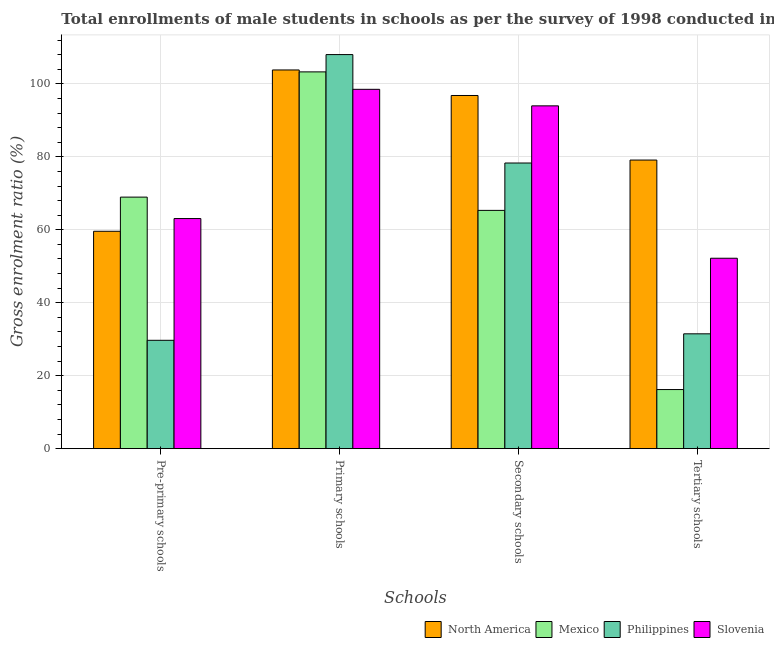Are the number of bars on each tick of the X-axis equal?
Provide a short and direct response. Yes. How many bars are there on the 1st tick from the left?
Your answer should be very brief. 4. How many bars are there on the 4th tick from the right?
Offer a very short reply. 4. What is the label of the 4th group of bars from the left?
Your response must be concise. Tertiary schools. What is the gross enrolment ratio(male) in primary schools in Philippines?
Ensure brevity in your answer.  108.04. Across all countries, what is the maximum gross enrolment ratio(male) in pre-primary schools?
Provide a succinct answer. 68.96. Across all countries, what is the minimum gross enrolment ratio(male) in secondary schools?
Give a very brief answer. 65.33. What is the total gross enrolment ratio(male) in tertiary schools in the graph?
Give a very brief answer. 179.03. What is the difference between the gross enrolment ratio(male) in primary schools in Mexico and that in Slovenia?
Your answer should be compact. 4.78. What is the difference between the gross enrolment ratio(male) in primary schools in Philippines and the gross enrolment ratio(male) in tertiary schools in Mexico?
Provide a short and direct response. 91.83. What is the average gross enrolment ratio(male) in pre-primary schools per country?
Provide a succinct answer. 55.34. What is the difference between the gross enrolment ratio(male) in tertiary schools and gross enrolment ratio(male) in secondary schools in Mexico?
Provide a short and direct response. -49.12. What is the ratio of the gross enrolment ratio(male) in primary schools in North America to that in Mexico?
Provide a succinct answer. 1.01. What is the difference between the highest and the second highest gross enrolment ratio(male) in tertiary schools?
Provide a succinct answer. 26.92. What is the difference between the highest and the lowest gross enrolment ratio(male) in primary schools?
Give a very brief answer. 9.53. Is it the case that in every country, the sum of the gross enrolment ratio(male) in tertiary schools and gross enrolment ratio(male) in secondary schools is greater than the sum of gross enrolment ratio(male) in primary schools and gross enrolment ratio(male) in pre-primary schools?
Your response must be concise. No. What does the 3rd bar from the left in Secondary schools represents?
Give a very brief answer. Philippines. What does the 1st bar from the right in Primary schools represents?
Keep it short and to the point. Slovenia. Are all the bars in the graph horizontal?
Offer a very short reply. No. Are the values on the major ticks of Y-axis written in scientific E-notation?
Your answer should be very brief. No. Does the graph contain any zero values?
Provide a succinct answer. No. Does the graph contain grids?
Your answer should be compact. Yes. How are the legend labels stacked?
Your answer should be very brief. Horizontal. What is the title of the graph?
Provide a succinct answer. Total enrollments of male students in schools as per the survey of 1998 conducted in different countries. Does "Low income" appear as one of the legend labels in the graph?
Your answer should be very brief. No. What is the label or title of the X-axis?
Provide a short and direct response. Schools. What is the label or title of the Y-axis?
Your response must be concise. Gross enrolment ratio (%). What is the Gross enrolment ratio (%) of North America in Pre-primary schools?
Provide a short and direct response. 59.6. What is the Gross enrolment ratio (%) of Mexico in Pre-primary schools?
Your response must be concise. 68.96. What is the Gross enrolment ratio (%) of Philippines in Pre-primary schools?
Provide a succinct answer. 29.71. What is the Gross enrolment ratio (%) of Slovenia in Pre-primary schools?
Your answer should be compact. 63.09. What is the Gross enrolment ratio (%) of North America in Primary schools?
Keep it short and to the point. 103.82. What is the Gross enrolment ratio (%) of Mexico in Primary schools?
Make the answer very short. 103.3. What is the Gross enrolment ratio (%) in Philippines in Primary schools?
Offer a very short reply. 108.04. What is the Gross enrolment ratio (%) of Slovenia in Primary schools?
Offer a very short reply. 98.52. What is the Gross enrolment ratio (%) of North America in Secondary schools?
Your response must be concise. 96.82. What is the Gross enrolment ratio (%) in Mexico in Secondary schools?
Your answer should be compact. 65.33. What is the Gross enrolment ratio (%) of Philippines in Secondary schools?
Your response must be concise. 78.31. What is the Gross enrolment ratio (%) of Slovenia in Secondary schools?
Keep it short and to the point. 93.98. What is the Gross enrolment ratio (%) of North America in Tertiary schools?
Provide a short and direct response. 79.12. What is the Gross enrolment ratio (%) in Mexico in Tertiary schools?
Your answer should be compact. 16.21. What is the Gross enrolment ratio (%) in Philippines in Tertiary schools?
Ensure brevity in your answer.  31.49. What is the Gross enrolment ratio (%) in Slovenia in Tertiary schools?
Provide a short and direct response. 52.21. Across all Schools, what is the maximum Gross enrolment ratio (%) in North America?
Provide a succinct answer. 103.82. Across all Schools, what is the maximum Gross enrolment ratio (%) in Mexico?
Your response must be concise. 103.3. Across all Schools, what is the maximum Gross enrolment ratio (%) in Philippines?
Provide a succinct answer. 108.04. Across all Schools, what is the maximum Gross enrolment ratio (%) of Slovenia?
Your answer should be very brief. 98.52. Across all Schools, what is the minimum Gross enrolment ratio (%) in North America?
Provide a succinct answer. 59.6. Across all Schools, what is the minimum Gross enrolment ratio (%) of Mexico?
Give a very brief answer. 16.21. Across all Schools, what is the minimum Gross enrolment ratio (%) in Philippines?
Offer a very short reply. 29.71. Across all Schools, what is the minimum Gross enrolment ratio (%) in Slovenia?
Provide a succinct answer. 52.21. What is the total Gross enrolment ratio (%) of North America in the graph?
Provide a succinct answer. 339.37. What is the total Gross enrolment ratio (%) in Mexico in the graph?
Your answer should be compact. 253.8. What is the total Gross enrolment ratio (%) in Philippines in the graph?
Offer a terse response. 247.55. What is the total Gross enrolment ratio (%) in Slovenia in the graph?
Give a very brief answer. 307.79. What is the difference between the Gross enrolment ratio (%) of North America in Pre-primary schools and that in Primary schools?
Offer a very short reply. -44.22. What is the difference between the Gross enrolment ratio (%) of Mexico in Pre-primary schools and that in Primary schools?
Your answer should be very brief. -34.33. What is the difference between the Gross enrolment ratio (%) in Philippines in Pre-primary schools and that in Primary schools?
Keep it short and to the point. -78.33. What is the difference between the Gross enrolment ratio (%) of Slovenia in Pre-primary schools and that in Primary schools?
Provide a short and direct response. -35.43. What is the difference between the Gross enrolment ratio (%) in North America in Pre-primary schools and that in Secondary schools?
Provide a short and direct response. -37.22. What is the difference between the Gross enrolment ratio (%) in Mexico in Pre-primary schools and that in Secondary schools?
Provide a succinct answer. 3.63. What is the difference between the Gross enrolment ratio (%) in Philippines in Pre-primary schools and that in Secondary schools?
Offer a terse response. -48.6. What is the difference between the Gross enrolment ratio (%) in Slovenia in Pre-primary schools and that in Secondary schools?
Provide a succinct answer. -30.9. What is the difference between the Gross enrolment ratio (%) in North America in Pre-primary schools and that in Tertiary schools?
Provide a short and direct response. -19.52. What is the difference between the Gross enrolment ratio (%) in Mexico in Pre-primary schools and that in Tertiary schools?
Keep it short and to the point. 52.76. What is the difference between the Gross enrolment ratio (%) in Philippines in Pre-primary schools and that in Tertiary schools?
Offer a very short reply. -1.78. What is the difference between the Gross enrolment ratio (%) in Slovenia in Pre-primary schools and that in Tertiary schools?
Your answer should be very brief. 10.88. What is the difference between the Gross enrolment ratio (%) of North America in Primary schools and that in Secondary schools?
Offer a very short reply. 7. What is the difference between the Gross enrolment ratio (%) of Mexico in Primary schools and that in Secondary schools?
Your answer should be compact. 37.97. What is the difference between the Gross enrolment ratio (%) in Philippines in Primary schools and that in Secondary schools?
Provide a short and direct response. 29.73. What is the difference between the Gross enrolment ratio (%) in Slovenia in Primary schools and that in Secondary schools?
Provide a succinct answer. 4.53. What is the difference between the Gross enrolment ratio (%) of North America in Primary schools and that in Tertiary schools?
Your response must be concise. 24.7. What is the difference between the Gross enrolment ratio (%) of Mexico in Primary schools and that in Tertiary schools?
Offer a very short reply. 87.09. What is the difference between the Gross enrolment ratio (%) in Philippines in Primary schools and that in Tertiary schools?
Your answer should be very brief. 76.55. What is the difference between the Gross enrolment ratio (%) in Slovenia in Primary schools and that in Tertiary schools?
Keep it short and to the point. 46.31. What is the difference between the Gross enrolment ratio (%) of North America in Secondary schools and that in Tertiary schools?
Provide a succinct answer. 17.7. What is the difference between the Gross enrolment ratio (%) of Mexico in Secondary schools and that in Tertiary schools?
Your answer should be compact. 49.12. What is the difference between the Gross enrolment ratio (%) of Philippines in Secondary schools and that in Tertiary schools?
Offer a terse response. 46.83. What is the difference between the Gross enrolment ratio (%) of Slovenia in Secondary schools and that in Tertiary schools?
Keep it short and to the point. 41.78. What is the difference between the Gross enrolment ratio (%) in North America in Pre-primary schools and the Gross enrolment ratio (%) in Mexico in Primary schools?
Provide a succinct answer. -43.7. What is the difference between the Gross enrolment ratio (%) in North America in Pre-primary schools and the Gross enrolment ratio (%) in Philippines in Primary schools?
Your answer should be compact. -48.44. What is the difference between the Gross enrolment ratio (%) in North America in Pre-primary schools and the Gross enrolment ratio (%) in Slovenia in Primary schools?
Give a very brief answer. -38.91. What is the difference between the Gross enrolment ratio (%) in Mexico in Pre-primary schools and the Gross enrolment ratio (%) in Philippines in Primary schools?
Provide a short and direct response. -39.08. What is the difference between the Gross enrolment ratio (%) in Mexico in Pre-primary schools and the Gross enrolment ratio (%) in Slovenia in Primary schools?
Offer a terse response. -29.55. What is the difference between the Gross enrolment ratio (%) in Philippines in Pre-primary schools and the Gross enrolment ratio (%) in Slovenia in Primary schools?
Offer a very short reply. -68.81. What is the difference between the Gross enrolment ratio (%) of North America in Pre-primary schools and the Gross enrolment ratio (%) of Mexico in Secondary schools?
Your answer should be very brief. -5.73. What is the difference between the Gross enrolment ratio (%) of North America in Pre-primary schools and the Gross enrolment ratio (%) of Philippines in Secondary schools?
Offer a very short reply. -18.71. What is the difference between the Gross enrolment ratio (%) of North America in Pre-primary schools and the Gross enrolment ratio (%) of Slovenia in Secondary schools?
Keep it short and to the point. -34.38. What is the difference between the Gross enrolment ratio (%) in Mexico in Pre-primary schools and the Gross enrolment ratio (%) in Philippines in Secondary schools?
Provide a short and direct response. -9.35. What is the difference between the Gross enrolment ratio (%) of Mexico in Pre-primary schools and the Gross enrolment ratio (%) of Slovenia in Secondary schools?
Your response must be concise. -25.02. What is the difference between the Gross enrolment ratio (%) in Philippines in Pre-primary schools and the Gross enrolment ratio (%) in Slovenia in Secondary schools?
Offer a very short reply. -64.27. What is the difference between the Gross enrolment ratio (%) of North America in Pre-primary schools and the Gross enrolment ratio (%) of Mexico in Tertiary schools?
Ensure brevity in your answer.  43.39. What is the difference between the Gross enrolment ratio (%) of North America in Pre-primary schools and the Gross enrolment ratio (%) of Philippines in Tertiary schools?
Make the answer very short. 28.11. What is the difference between the Gross enrolment ratio (%) of North America in Pre-primary schools and the Gross enrolment ratio (%) of Slovenia in Tertiary schools?
Your answer should be very brief. 7.39. What is the difference between the Gross enrolment ratio (%) of Mexico in Pre-primary schools and the Gross enrolment ratio (%) of Philippines in Tertiary schools?
Provide a short and direct response. 37.47. What is the difference between the Gross enrolment ratio (%) of Mexico in Pre-primary schools and the Gross enrolment ratio (%) of Slovenia in Tertiary schools?
Give a very brief answer. 16.76. What is the difference between the Gross enrolment ratio (%) of Philippines in Pre-primary schools and the Gross enrolment ratio (%) of Slovenia in Tertiary schools?
Your answer should be compact. -22.5. What is the difference between the Gross enrolment ratio (%) in North America in Primary schools and the Gross enrolment ratio (%) in Mexico in Secondary schools?
Your answer should be compact. 38.5. What is the difference between the Gross enrolment ratio (%) of North America in Primary schools and the Gross enrolment ratio (%) of Philippines in Secondary schools?
Your answer should be very brief. 25.51. What is the difference between the Gross enrolment ratio (%) in North America in Primary schools and the Gross enrolment ratio (%) in Slovenia in Secondary schools?
Your answer should be very brief. 9.84. What is the difference between the Gross enrolment ratio (%) in Mexico in Primary schools and the Gross enrolment ratio (%) in Philippines in Secondary schools?
Offer a very short reply. 24.98. What is the difference between the Gross enrolment ratio (%) of Mexico in Primary schools and the Gross enrolment ratio (%) of Slovenia in Secondary schools?
Your response must be concise. 9.31. What is the difference between the Gross enrolment ratio (%) of Philippines in Primary schools and the Gross enrolment ratio (%) of Slovenia in Secondary schools?
Your answer should be compact. 14.06. What is the difference between the Gross enrolment ratio (%) of North America in Primary schools and the Gross enrolment ratio (%) of Mexico in Tertiary schools?
Your answer should be very brief. 87.62. What is the difference between the Gross enrolment ratio (%) in North America in Primary schools and the Gross enrolment ratio (%) in Philippines in Tertiary schools?
Make the answer very short. 72.34. What is the difference between the Gross enrolment ratio (%) in North America in Primary schools and the Gross enrolment ratio (%) in Slovenia in Tertiary schools?
Ensure brevity in your answer.  51.62. What is the difference between the Gross enrolment ratio (%) in Mexico in Primary schools and the Gross enrolment ratio (%) in Philippines in Tertiary schools?
Your answer should be very brief. 71.81. What is the difference between the Gross enrolment ratio (%) in Mexico in Primary schools and the Gross enrolment ratio (%) in Slovenia in Tertiary schools?
Keep it short and to the point. 51.09. What is the difference between the Gross enrolment ratio (%) in Philippines in Primary schools and the Gross enrolment ratio (%) in Slovenia in Tertiary schools?
Provide a succinct answer. 55.83. What is the difference between the Gross enrolment ratio (%) of North America in Secondary schools and the Gross enrolment ratio (%) of Mexico in Tertiary schools?
Your response must be concise. 80.62. What is the difference between the Gross enrolment ratio (%) in North America in Secondary schools and the Gross enrolment ratio (%) in Philippines in Tertiary schools?
Provide a short and direct response. 65.34. What is the difference between the Gross enrolment ratio (%) of North America in Secondary schools and the Gross enrolment ratio (%) of Slovenia in Tertiary schools?
Your response must be concise. 44.62. What is the difference between the Gross enrolment ratio (%) in Mexico in Secondary schools and the Gross enrolment ratio (%) in Philippines in Tertiary schools?
Give a very brief answer. 33.84. What is the difference between the Gross enrolment ratio (%) in Mexico in Secondary schools and the Gross enrolment ratio (%) in Slovenia in Tertiary schools?
Your response must be concise. 13.12. What is the difference between the Gross enrolment ratio (%) in Philippines in Secondary schools and the Gross enrolment ratio (%) in Slovenia in Tertiary schools?
Provide a short and direct response. 26.11. What is the average Gross enrolment ratio (%) of North America per Schools?
Ensure brevity in your answer.  84.84. What is the average Gross enrolment ratio (%) in Mexico per Schools?
Offer a very short reply. 63.45. What is the average Gross enrolment ratio (%) of Philippines per Schools?
Make the answer very short. 61.89. What is the average Gross enrolment ratio (%) of Slovenia per Schools?
Give a very brief answer. 76.95. What is the difference between the Gross enrolment ratio (%) in North America and Gross enrolment ratio (%) in Mexico in Pre-primary schools?
Your response must be concise. -9.36. What is the difference between the Gross enrolment ratio (%) of North America and Gross enrolment ratio (%) of Philippines in Pre-primary schools?
Ensure brevity in your answer.  29.89. What is the difference between the Gross enrolment ratio (%) of North America and Gross enrolment ratio (%) of Slovenia in Pre-primary schools?
Your answer should be very brief. -3.48. What is the difference between the Gross enrolment ratio (%) in Mexico and Gross enrolment ratio (%) in Philippines in Pre-primary schools?
Provide a short and direct response. 39.25. What is the difference between the Gross enrolment ratio (%) of Mexico and Gross enrolment ratio (%) of Slovenia in Pre-primary schools?
Keep it short and to the point. 5.88. What is the difference between the Gross enrolment ratio (%) in Philippines and Gross enrolment ratio (%) in Slovenia in Pre-primary schools?
Your answer should be compact. -33.38. What is the difference between the Gross enrolment ratio (%) of North America and Gross enrolment ratio (%) of Mexico in Primary schools?
Provide a short and direct response. 0.53. What is the difference between the Gross enrolment ratio (%) of North America and Gross enrolment ratio (%) of Philippines in Primary schools?
Ensure brevity in your answer.  -4.22. What is the difference between the Gross enrolment ratio (%) in North America and Gross enrolment ratio (%) in Slovenia in Primary schools?
Offer a very short reply. 5.31. What is the difference between the Gross enrolment ratio (%) in Mexico and Gross enrolment ratio (%) in Philippines in Primary schools?
Your answer should be compact. -4.74. What is the difference between the Gross enrolment ratio (%) of Mexico and Gross enrolment ratio (%) of Slovenia in Primary schools?
Offer a very short reply. 4.78. What is the difference between the Gross enrolment ratio (%) in Philippines and Gross enrolment ratio (%) in Slovenia in Primary schools?
Make the answer very short. 9.53. What is the difference between the Gross enrolment ratio (%) of North America and Gross enrolment ratio (%) of Mexico in Secondary schools?
Offer a very short reply. 31.49. What is the difference between the Gross enrolment ratio (%) in North America and Gross enrolment ratio (%) in Philippines in Secondary schools?
Offer a terse response. 18.51. What is the difference between the Gross enrolment ratio (%) of North America and Gross enrolment ratio (%) of Slovenia in Secondary schools?
Offer a terse response. 2.84. What is the difference between the Gross enrolment ratio (%) of Mexico and Gross enrolment ratio (%) of Philippines in Secondary schools?
Keep it short and to the point. -12.99. What is the difference between the Gross enrolment ratio (%) in Mexico and Gross enrolment ratio (%) in Slovenia in Secondary schools?
Make the answer very short. -28.66. What is the difference between the Gross enrolment ratio (%) of Philippines and Gross enrolment ratio (%) of Slovenia in Secondary schools?
Ensure brevity in your answer.  -15.67. What is the difference between the Gross enrolment ratio (%) in North America and Gross enrolment ratio (%) in Mexico in Tertiary schools?
Ensure brevity in your answer.  62.92. What is the difference between the Gross enrolment ratio (%) in North America and Gross enrolment ratio (%) in Philippines in Tertiary schools?
Your answer should be compact. 47.64. What is the difference between the Gross enrolment ratio (%) of North America and Gross enrolment ratio (%) of Slovenia in Tertiary schools?
Offer a very short reply. 26.92. What is the difference between the Gross enrolment ratio (%) in Mexico and Gross enrolment ratio (%) in Philippines in Tertiary schools?
Keep it short and to the point. -15.28. What is the difference between the Gross enrolment ratio (%) in Mexico and Gross enrolment ratio (%) in Slovenia in Tertiary schools?
Offer a terse response. -36. What is the difference between the Gross enrolment ratio (%) in Philippines and Gross enrolment ratio (%) in Slovenia in Tertiary schools?
Offer a very short reply. -20.72. What is the ratio of the Gross enrolment ratio (%) in North America in Pre-primary schools to that in Primary schools?
Provide a succinct answer. 0.57. What is the ratio of the Gross enrolment ratio (%) in Mexico in Pre-primary schools to that in Primary schools?
Your response must be concise. 0.67. What is the ratio of the Gross enrolment ratio (%) in Philippines in Pre-primary schools to that in Primary schools?
Your answer should be compact. 0.28. What is the ratio of the Gross enrolment ratio (%) of Slovenia in Pre-primary schools to that in Primary schools?
Make the answer very short. 0.64. What is the ratio of the Gross enrolment ratio (%) of North America in Pre-primary schools to that in Secondary schools?
Keep it short and to the point. 0.62. What is the ratio of the Gross enrolment ratio (%) in Mexico in Pre-primary schools to that in Secondary schools?
Your answer should be very brief. 1.06. What is the ratio of the Gross enrolment ratio (%) of Philippines in Pre-primary schools to that in Secondary schools?
Keep it short and to the point. 0.38. What is the ratio of the Gross enrolment ratio (%) in Slovenia in Pre-primary schools to that in Secondary schools?
Your answer should be very brief. 0.67. What is the ratio of the Gross enrolment ratio (%) in North America in Pre-primary schools to that in Tertiary schools?
Offer a very short reply. 0.75. What is the ratio of the Gross enrolment ratio (%) of Mexico in Pre-primary schools to that in Tertiary schools?
Provide a short and direct response. 4.26. What is the ratio of the Gross enrolment ratio (%) in Philippines in Pre-primary schools to that in Tertiary schools?
Offer a very short reply. 0.94. What is the ratio of the Gross enrolment ratio (%) of Slovenia in Pre-primary schools to that in Tertiary schools?
Provide a short and direct response. 1.21. What is the ratio of the Gross enrolment ratio (%) of North America in Primary schools to that in Secondary schools?
Offer a very short reply. 1.07. What is the ratio of the Gross enrolment ratio (%) of Mexico in Primary schools to that in Secondary schools?
Ensure brevity in your answer.  1.58. What is the ratio of the Gross enrolment ratio (%) of Philippines in Primary schools to that in Secondary schools?
Make the answer very short. 1.38. What is the ratio of the Gross enrolment ratio (%) in Slovenia in Primary schools to that in Secondary schools?
Make the answer very short. 1.05. What is the ratio of the Gross enrolment ratio (%) in North America in Primary schools to that in Tertiary schools?
Your answer should be very brief. 1.31. What is the ratio of the Gross enrolment ratio (%) of Mexico in Primary schools to that in Tertiary schools?
Offer a very short reply. 6.37. What is the ratio of the Gross enrolment ratio (%) of Philippines in Primary schools to that in Tertiary schools?
Provide a short and direct response. 3.43. What is the ratio of the Gross enrolment ratio (%) of Slovenia in Primary schools to that in Tertiary schools?
Offer a terse response. 1.89. What is the ratio of the Gross enrolment ratio (%) of North America in Secondary schools to that in Tertiary schools?
Provide a short and direct response. 1.22. What is the ratio of the Gross enrolment ratio (%) of Mexico in Secondary schools to that in Tertiary schools?
Make the answer very short. 4.03. What is the ratio of the Gross enrolment ratio (%) of Philippines in Secondary schools to that in Tertiary schools?
Ensure brevity in your answer.  2.49. What is the ratio of the Gross enrolment ratio (%) of Slovenia in Secondary schools to that in Tertiary schools?
Give a very brief answer. 1.8. What is the difference between the highest and the second highest Gross enrolment ratio (%) of North America?
Your answer should be compact. 7. What is the difference between the highest and the second highest Gross enrolment ratio (%) of Mexico?
Provide a succinct answer. 34.33. What is the difference between the highest and the second highest Gross enrolment ratio (%) of Philippines?
Give a very brief answer. 29.73. What is the difference between the highest and the second highest Gross enrolment ratio (%) in Slovenia?
Offer a terse response. 4.53. What is the difference between the highest and the lowest Gross enrolment ratio (%) in North America?
Your answer should be compact. 44.22. What is the difference between the highest and the lowest Gross enrolment ratio (%) in Mexico?
Give a very brief answer. 87.09. What is the difference between the highest and the lowest Gross enrolment ratio (%) in Philippines?
Offer a very short reply. 78.33. What is the difference between the highest and the lowest Gross enrolment ratio (%) in Slovenia?
Offer a very short reply. 46.31. 